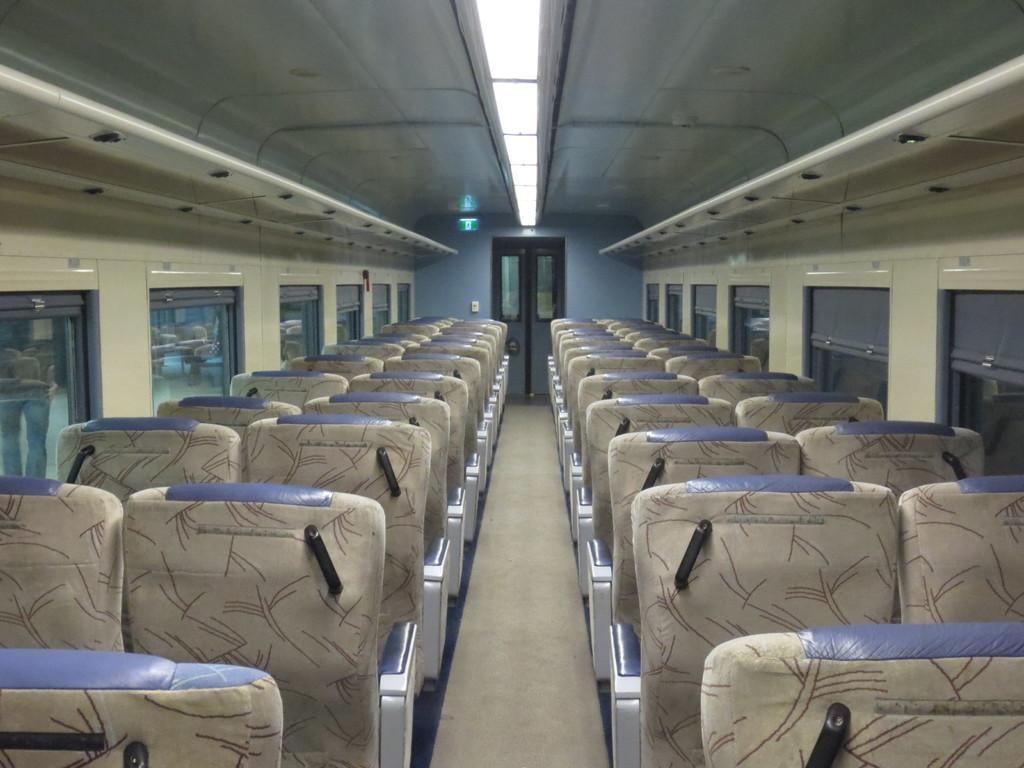Describe this image in one or two sentences. In this image I can observe empty seats. On the top there are lights. 